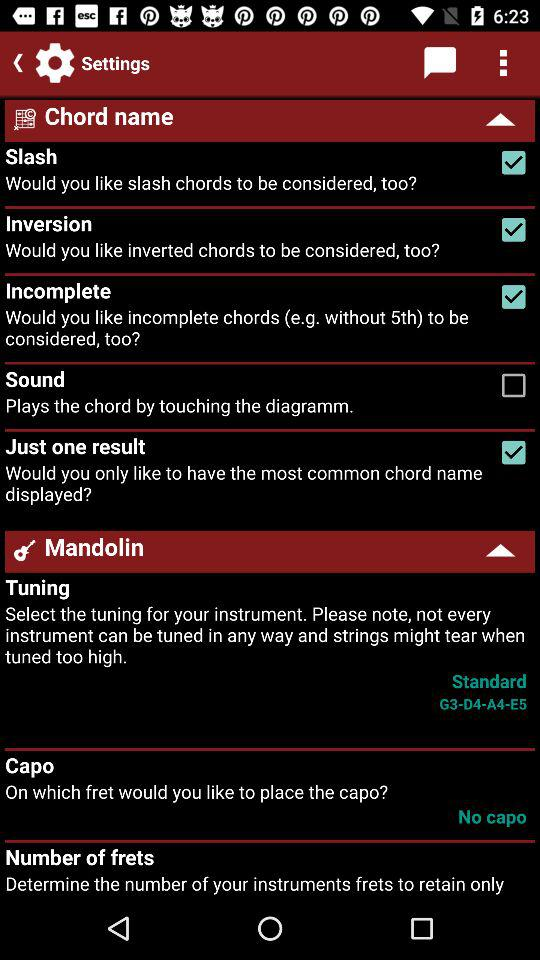What is the tuning standard given on the screen? The given tuning standard is G3-D4-A4-E5. 